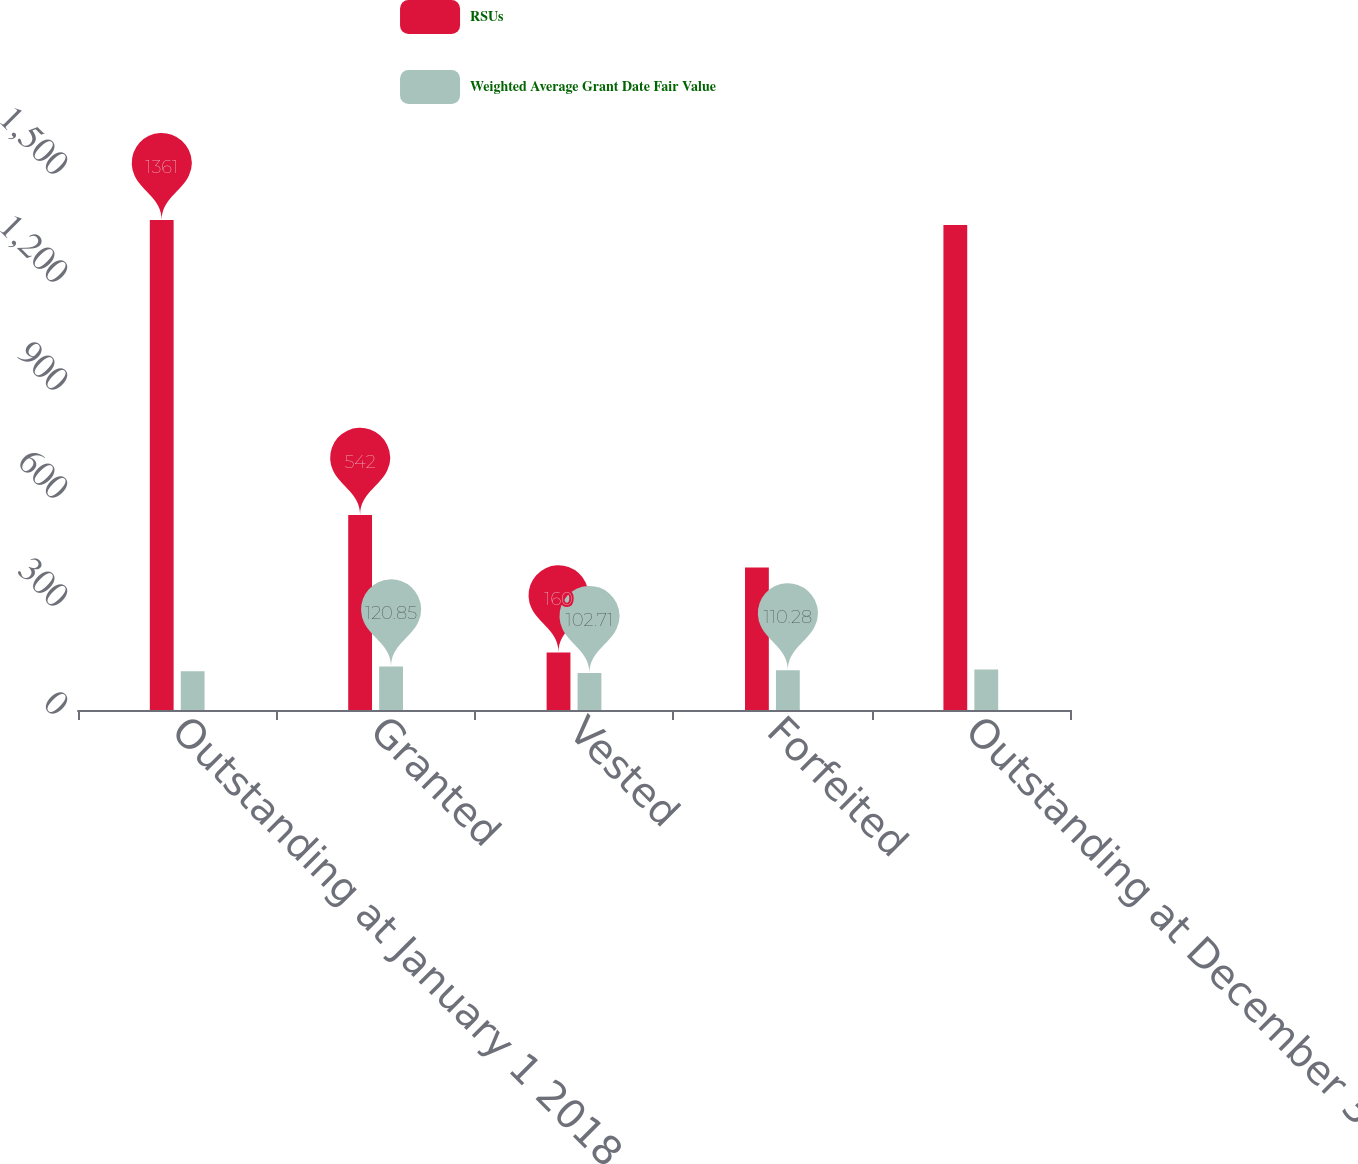Convert chart. <chart><loc_0><loc_0><loc_500><loc_500><stacked_bar_chart><ecel><fcel>Outstanding at January 1 2018<fcel>Granted<fcel>Vested<fcel>Forfeited<fcel>Outstanding at December 31<nl><fcel>RSUs<fcel>1361<fcel>542<fcel>160<fcel>396<fcel>1347<nl><fcel>Weighted Average Grant Date Fair Value<fcel>107.56<fcel>120.85<fcel>102.71<fcel>110.28<fcel>112.81<nl></chart> 